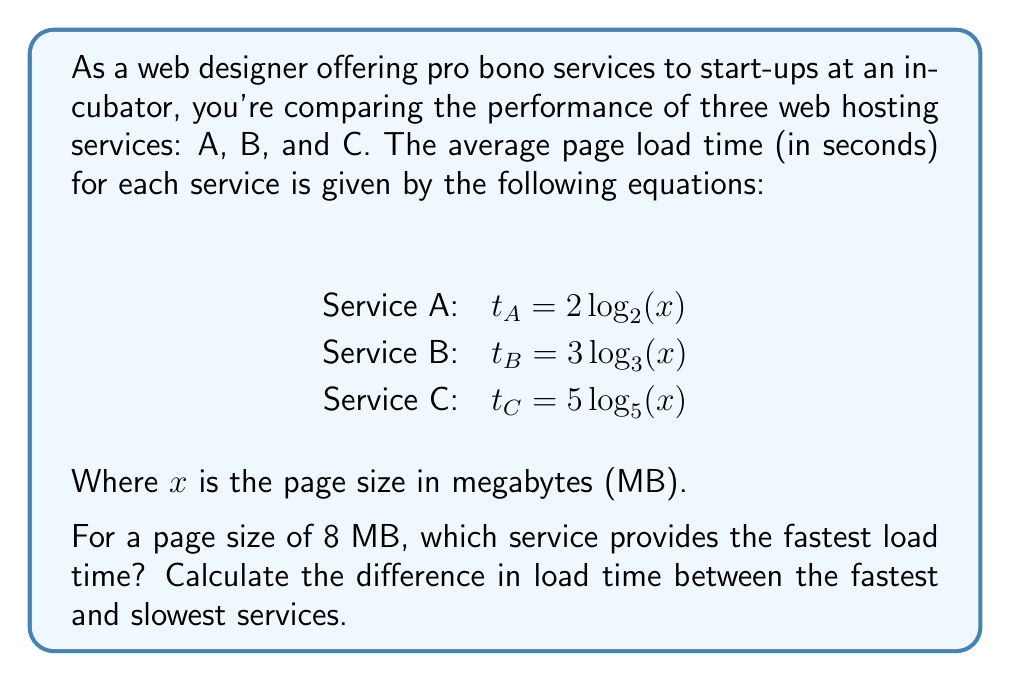What is the answer to this math problem? To solve this problem, we need to calculate the load time for each service with a page size of 8 MB and compare the results.

1. For Service A:
   $t_A = 2 \log_2(8)$
   $= 2 \cdot 3$ (since $2^3 = 8$)
   $= 6$ seconds

2. For Service B:
   $t_B = 3 \log_3(8)$
   $= 3 \cdot \frac{\log(8)}{\log(3)}$ (change of base formula)
   $\approx 5.67$ seconds

3. For Service C:
   $t_C = 5 log_5(8)$
   $= 5 \cdot \frac{\log(8)}{\log(5)}$ (change of base formula)
   $\approx 4.51$ seconds

Comparing the results:
Service C: 4.51 seconds
Service B: 5.67 seconds
Service A: 6.00 seconds

Service C provides the fastest load time.

To calculate the difference between the fastest and slowest services:
$6.00 - 4.51 = 1.49$ seconds
Answer: Service C provides the fastest load time. The difference in load time between the fastest (Service C) and slowest (Service A) is approximately 1.49 seconds. 